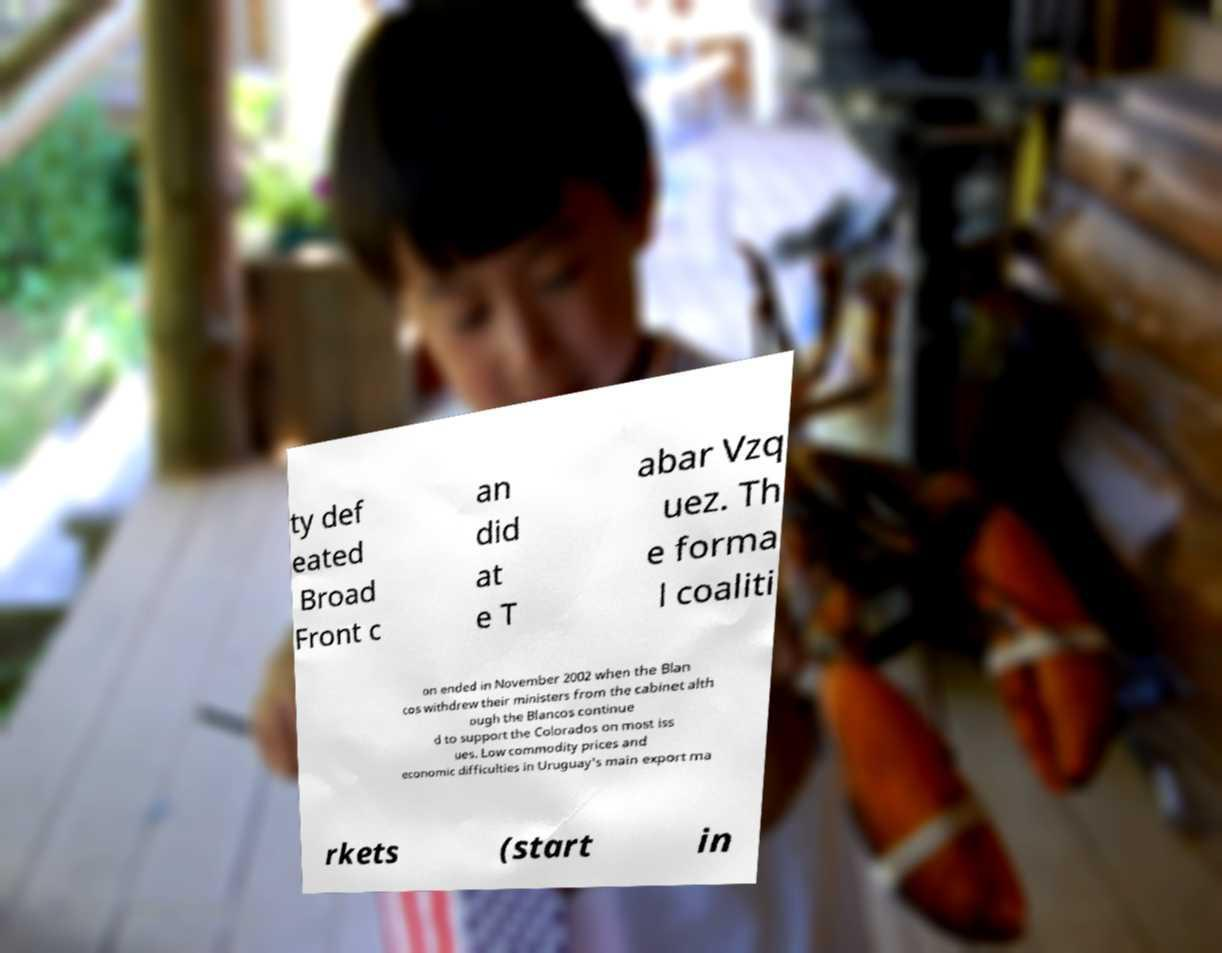What messages or text are displayed in this image? I need them in a readable, typed format. ty def eated Broad Front c an did at e T abar Vzq uez. Th e forma l coaliti on ended in November 2002 when the Blan cos withdrew their ministers from the cabinet alth ough the Blancos continue d to support the Colorados on most iss ues. Low commodity prices and economic difficulties in Uruguay's main export ma rkets (start in 